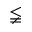<formula> <loc_0><loc_0><loc_500><loc_500>\lneqq</formula> 